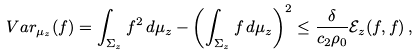Convert formula to latex. <formula><loc_0><loc_0><loc_500><loc_500>V a r _ { \mu _ { z } } ( f ) = \int _ { \Sigma _ { z } } f ^ { 2 } \, d \mu _ { z } - \left ( \int _ { \Sigma _ { z } } f \, d \mu _ { z } \right ) ^ { 2 } \leq \frac { \delta } { c _ { 2 } \rho _ { 0 } } \mathcal { E } _ { z } ( f , f ) \, ,</formula> 